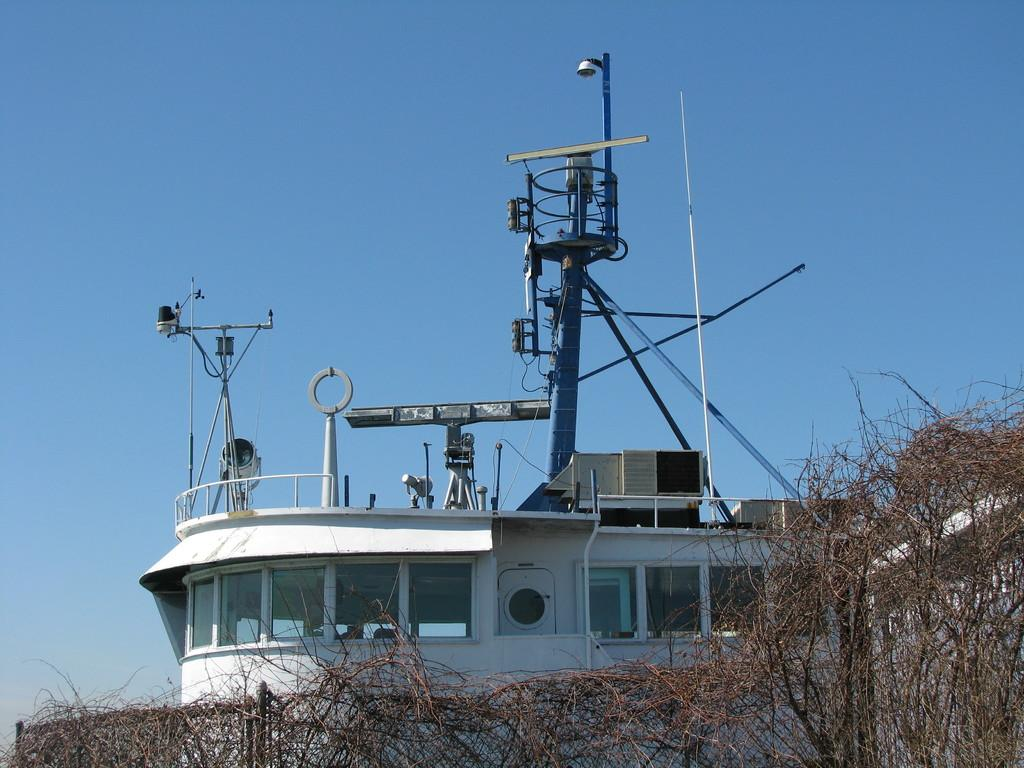What type of structure is in the picture? There is a house in the picture. What are some notable features of the house? The house has towers and glass windows. What can be seen near the house? There is a fence in the picture. What is the fence made of? The fence has twigs. What is the condition of the sky in the picture? The sky is clear in the picture. How many rabbits can be seen playing with their brothers near the cat in the image? There are no rabbits, brothers, or cats present in the image. 